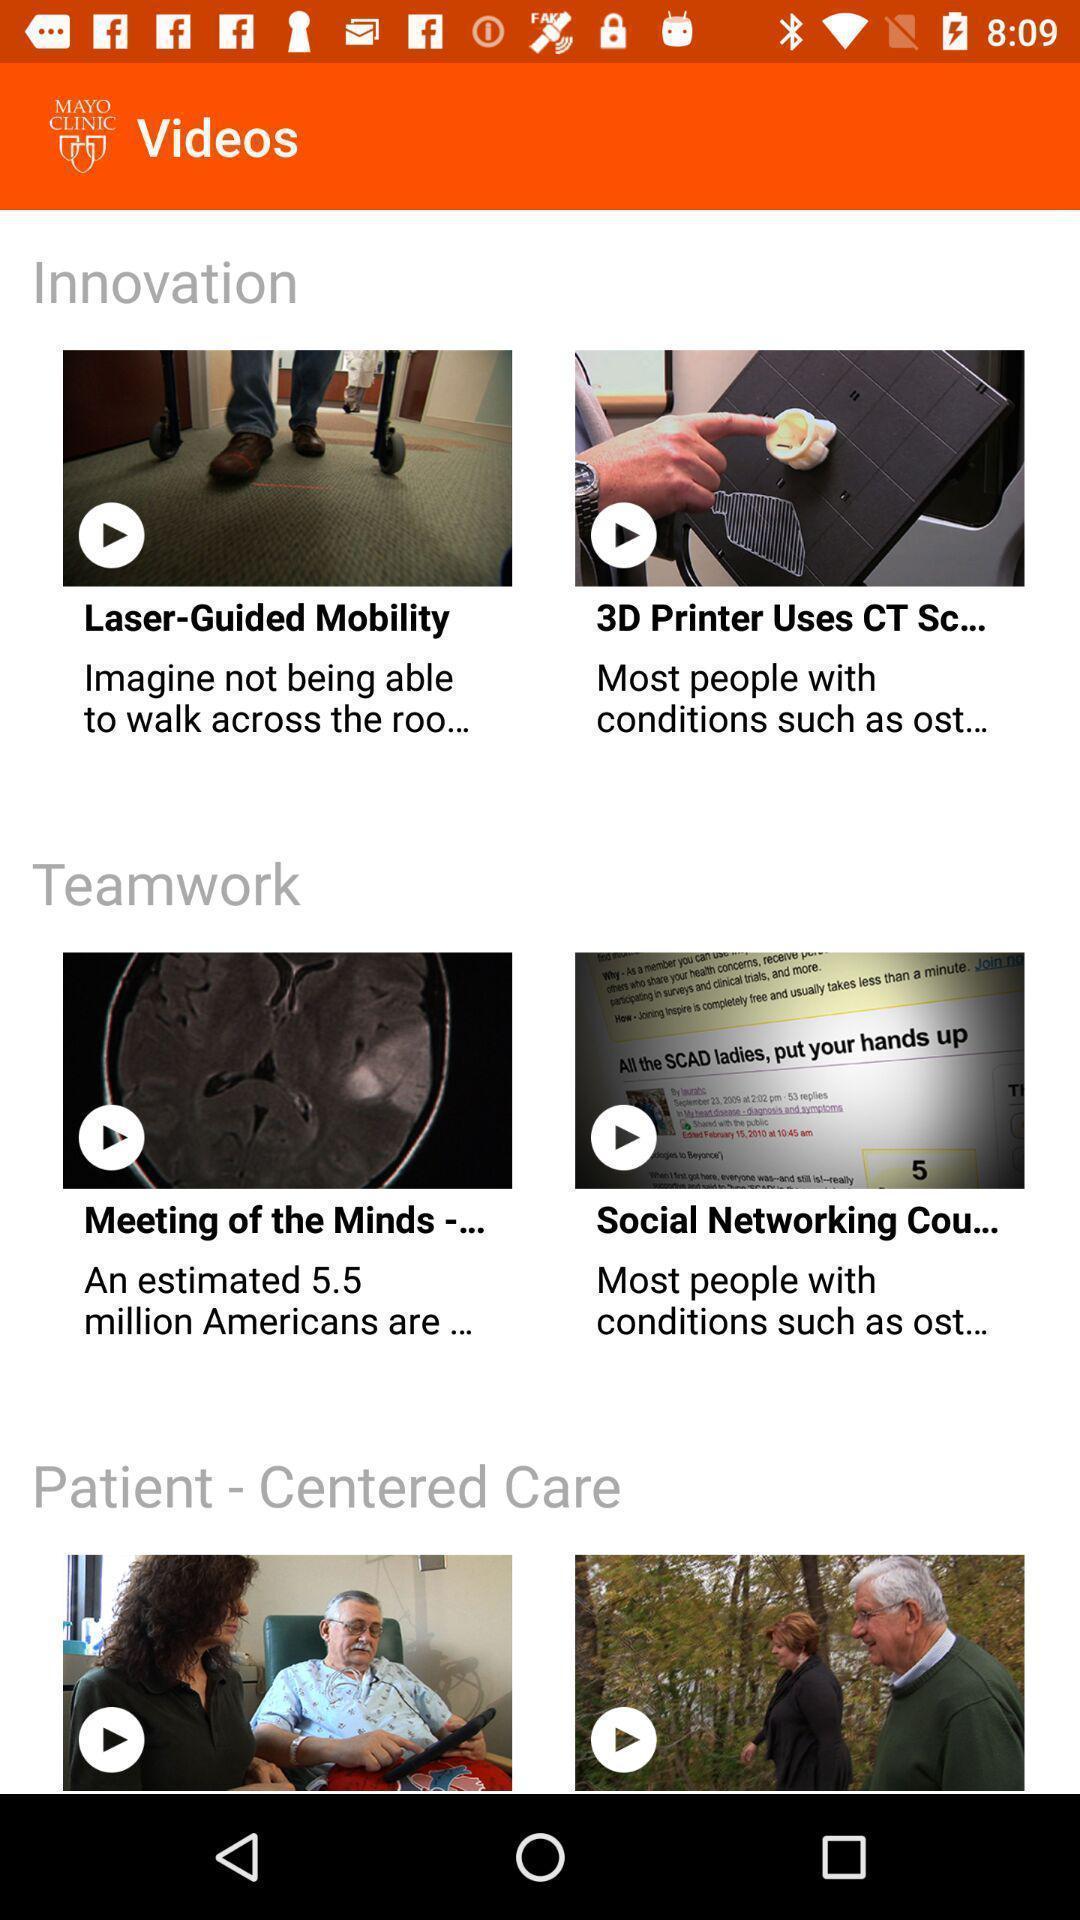Give me a narrative description of this picture. Screen displaying the list of videos. 